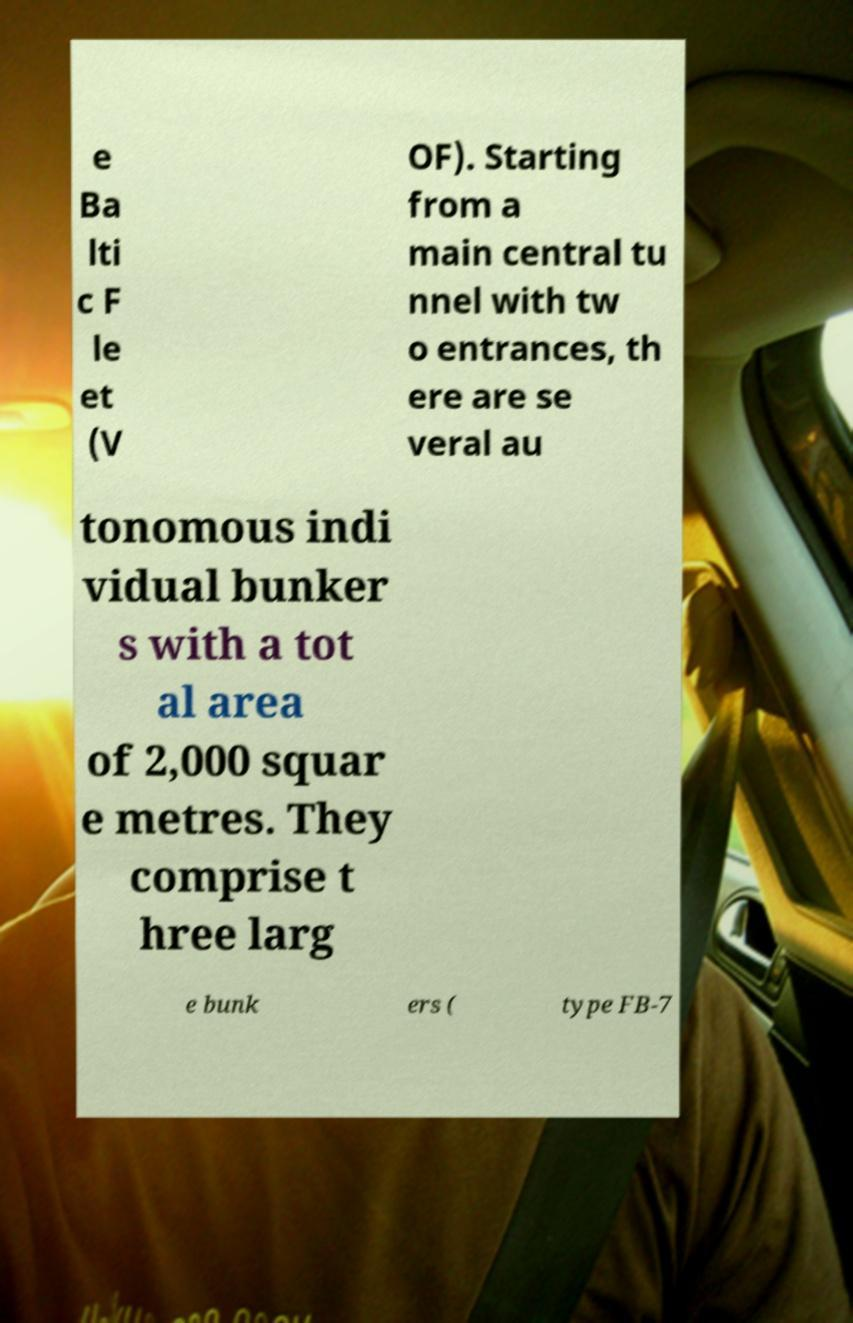Can you accurately transcribe the text from the provided image for me? e Ba lti c F le et (V OF). Starting from a main central tu nnel with tw o entrances, th ere are se veral au tonomous indi vidual bunker s with a tot al area of 2,000 squar e metres. They comprise t hree larg e bunk ers ( type FB-7 